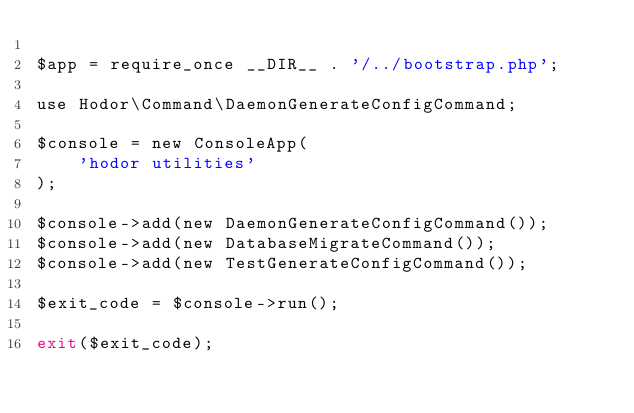<code> <loc_0><loc_0><loc_500><loc_500><_PHP_>
$app = require_once __DIR__ . '/../bootstrap.php';

use Hodor\Command\DaemonGenerateConfigCommand;

$console = new ConsoleApp(
    'hodor utilities'
);

$console->add(new DaemonGenerateConfigCommand());
$console->add(new DatabaseMigrateCommand());
$console->add(new TestGenerateConfigCommand());

$exit_code = $console->run();

exit($exit_code);
</code> 